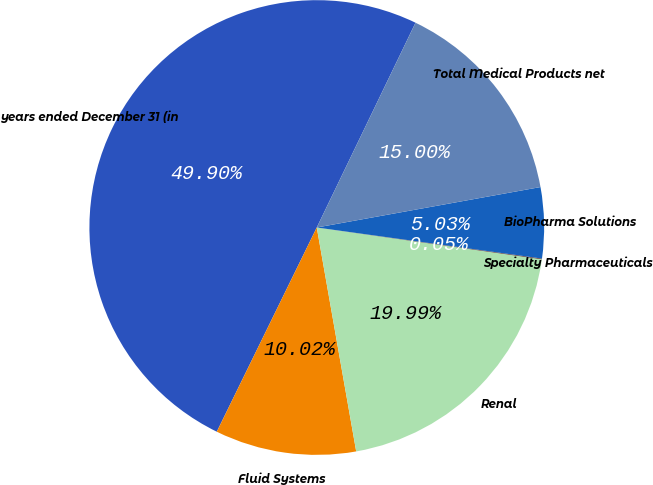Convert chart. <chart><loc_0><loc_0><loc_500><loc_500><pie_chart><fcel>years ended December 31 (in<fcel>Fluid Systems<fcel>Renal<fcel>Specialty Pharmaceuticals<fcel>BioPharma Solutions<fcel>Total Medical Products net<nl><fcel>49.9%<fcel>10.02%<fcel>19.99%<fcel>0.05%<fcel>5.03%<fcel>15.0%<nl></chart> 